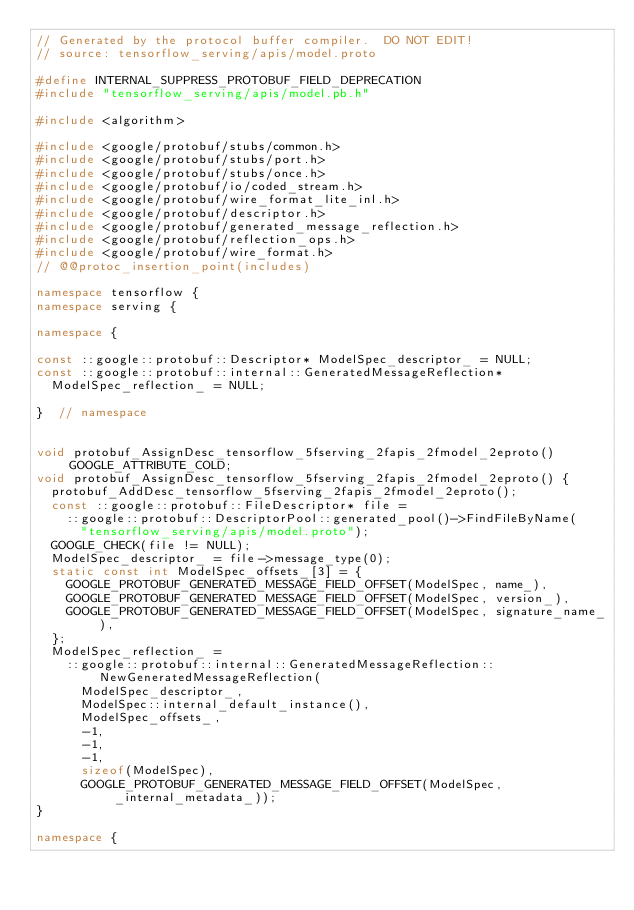<code> <loc_0><loc_0><loc_500><loc_500><_C++_>// Generated by the protocol buffer compiler.  DO NOT EDIT!
// source: tensorflow_serving/apis/model.proto

#define INTERNAL_SUPPRESS_PROTOBUF_FIELD_DEPRECATION
#include "tensorflow_serving/apis/model.pb.h"

#include <algorithm>

#include <google/protobuf/stubs/common.h>
#include <google/protobuf/stubs/port.h>
#include <google/protobuf/stubs/once.h>
#include <google/protobuf/io/coded_stream.h>
#include <google/protobuf/wire_format_lite_inl.h>
#include <google/protobuf/descriptor.h>
#include <google/protobuf/generated_message_reflection.h>
#include <google/protobuf/reflection_ops.h>
#include <google/protobuf/wire_format.h>
// @@protoc_insertion_point(includes)

namespace tensorflow {
namespace serving {

namespace {

const ::google::protobuf::Descriptor* ModelSpec_descriptor_ = NULL;
const ::google::protobuf::internal::GeneratedMessageReflection*
  ModelSpec_reflection_ = NULL;

}  // namespace


void protobuf_AssignDesc_tensorflow_5fserving_2fapis_2fmodel_2eproto() GOOGLE_ATTRIBUTE_COLD;
void protobuf_AssignDesc_tensorflow_5fserving_2fapis_2fmodel_2eproto() {
  protobuf_AddDesc_tensorflow_5fserving_2fapis_2fmodel_2eproto();
  const ::google::protobuf::FileDescriptor* file =
    ::google::protobuf::DescriptorPool::generated_pool()->FindFileByName(
      "tensorflow_serving/apis/model.proto");
  GOOGLE_CHECK(file != NULL);
  ModelSpec_descriptor_ = file->message_type(0);
  static const int ModelSpec_offsets_[3] = {
    GOOGLE_PROTOBUF_GENERATED_MESSAGE_FIELD_OFFSET(ModelSpec, name_),
    GOOGLE_PROTOBUF_GENERATED_MESSAGE_FIELD_OFFSET(ModelSpec, version_),
    GOOGLE_PROTOBUF_GENERATED_MESSAGE_FIELD_OFFSET(ModelSpec, signature_name_),
  };
  ModelSpec_reflection_ =
    ::google::protobuf::internal::GeneratedMessageReflection::NewGeneratedMessageReflection(
      ModelSpec_descriptor_,
      ModelSpec::internal_default_instance(),
      ModelSpec_offsets_,
      -1,
      -1,
      -1,
      sizeof(ModelSpec),
      GOOGLE_PROTOBUF_GENERATED_MESSAGE_FIELD_OFFSET(ModelSpec, _internal_metadata_));
}

namespace {
</code> 